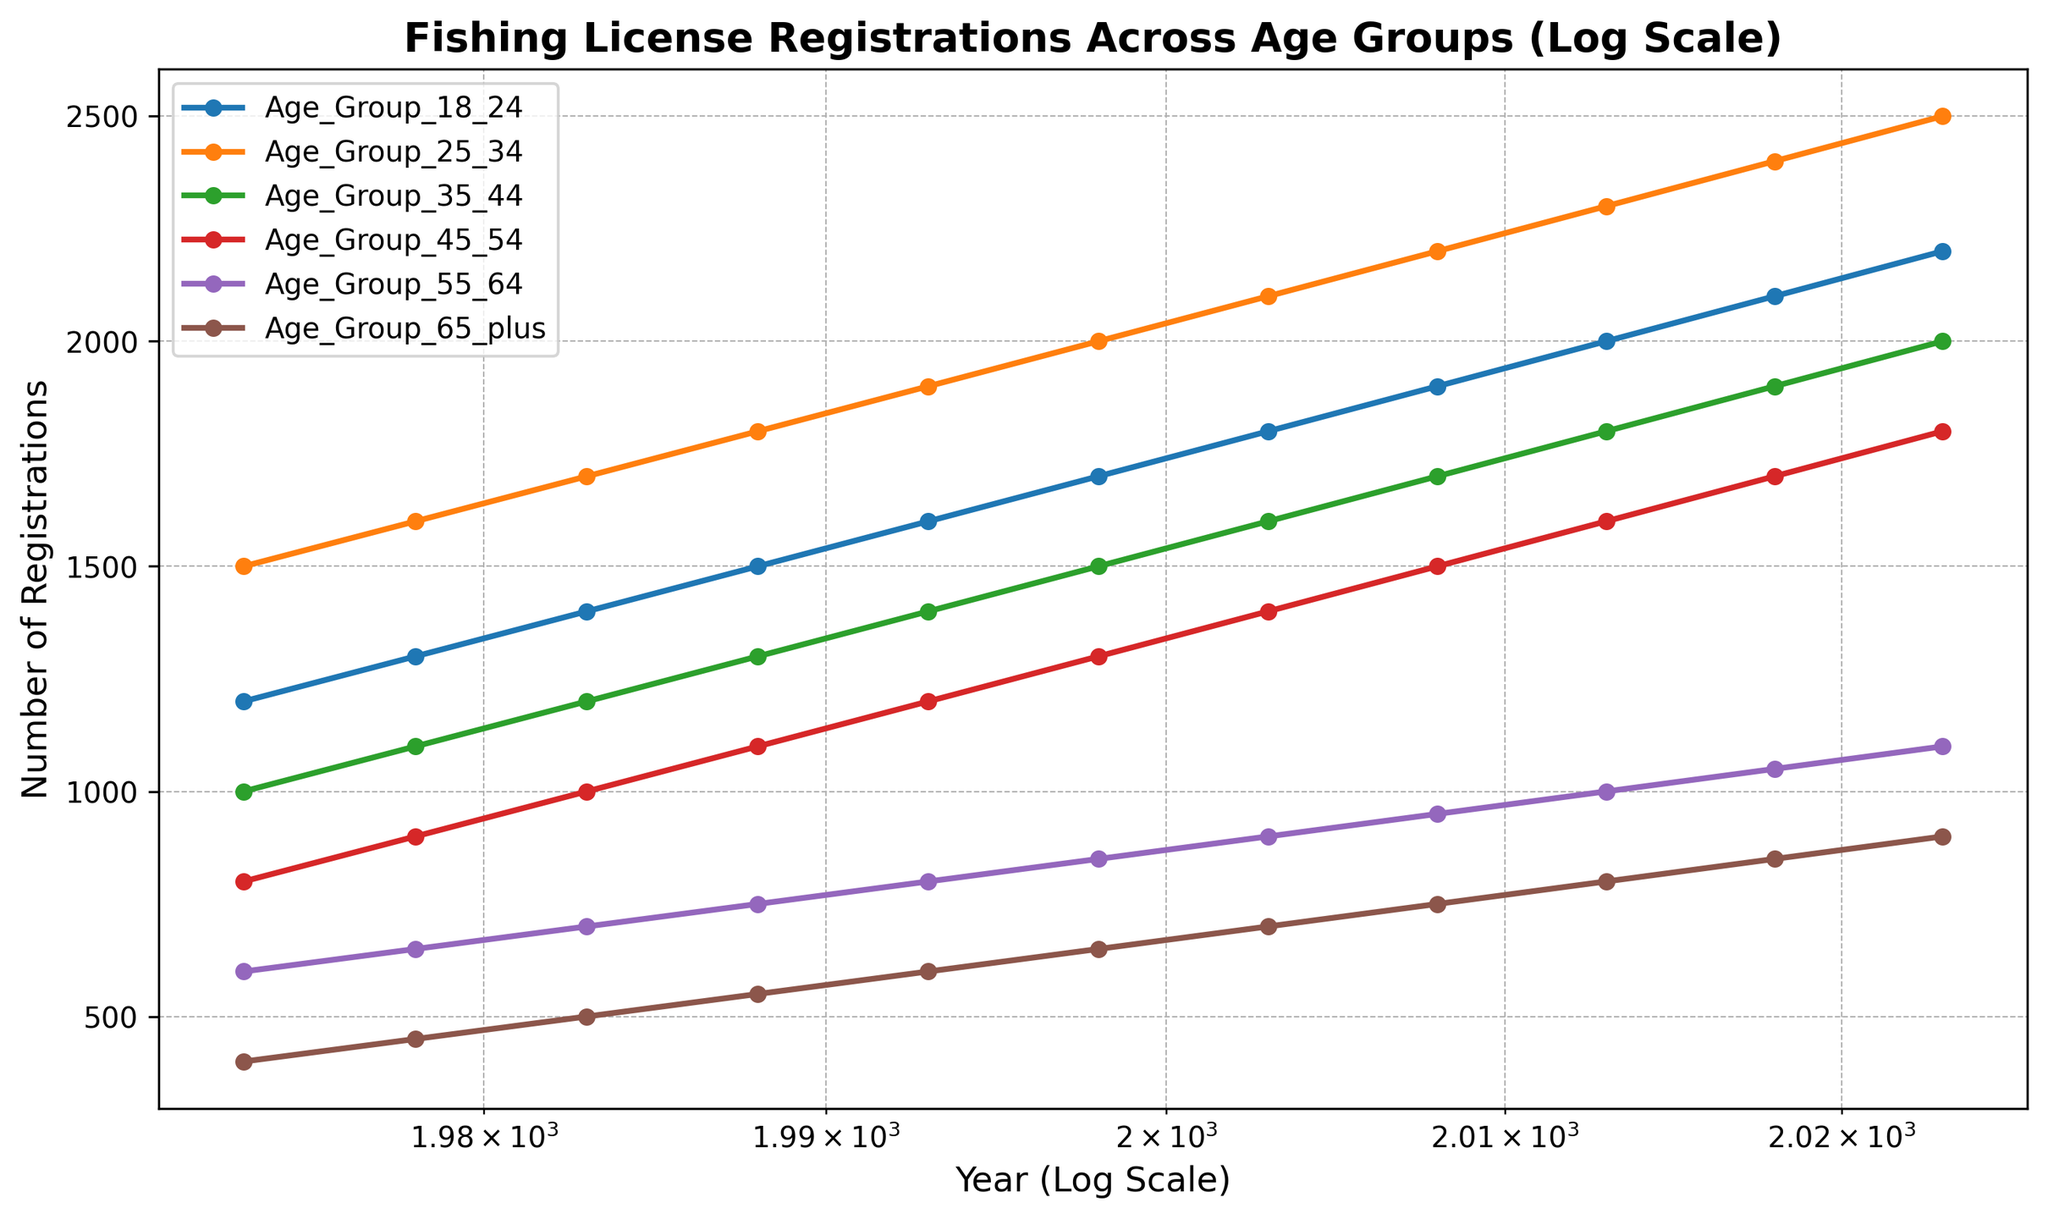What age group had the highest number of fishing license registrations in 2023? In 2023, the Age Group 25_34 had the highest value of around 2500 on the chart.
Answer: Age Group 25_34 Which age group showed the least growth in fishing license registrations from 1973 to 2023? The Age Group 65_plus increased from 400 registrations in 1973 to 900 in 2023, a difference of 500. The other age groups had larger increases.
Answer: Age Group 65_plus By how much did the fishing license registrations for the Age Group 18_24 change from 1973 to 1983? The number of registrations for Age Group 18_24 was 1200 in 1973 and 1400 in 1983. The change is 1400 - 1200 = 200.
Answer: 200 Compare the registration numbers for Age Group 45_54 in 1978 and 2023. Are they less than or more than double? In 1978, the registration number was 900, and in 2023 it was 1800. Comparing, 1800 is more than double 900.
Answer: More What is the average number of registrations for Age Group 55_64 over the years 1973, 1983, 1993, and 2003? The values for Age Group 55_64 in these years are 600, 700, 800, and 900 respectively. Summing these gives 3000, and the average is 3000 / 4 = 750.
Answer: 750 From the visual representation, which age group had the steepest increase in registrations from 2003 to 2023? The steepest increase is indicated by the steepest slope on the chart. Age Group 25_34 showed the steepest increase from 2100 in 2003 to 2500 in 2023, an increase of 400.
Answer: Age Group 25_34 Did any age group's registration numbers decrease over the years shown in the chart? By visually examining the chart, all lines show an upward trend, indicating that registration numbers increased for all age groups over the years.
Answer: No In which year did the difference in registrations between Age Group 18_24 and Age Group 65_plus become the largest? The largest difference visually appears to be in 2023, where Age Group 18_24 had 2200 registrations and Age Group 65_plus had 900. The difference is 1300.
Answer: 2023 What was the average number of registrations for all age groups in 2013? The values for 2013 are 2000, 2300, 1800, 1600, 1000, and 800. Summing these gives 9500, and dividing by the number of groups (6) gives 9500 / 6 = 1583.33.
Answer: 1583.33 